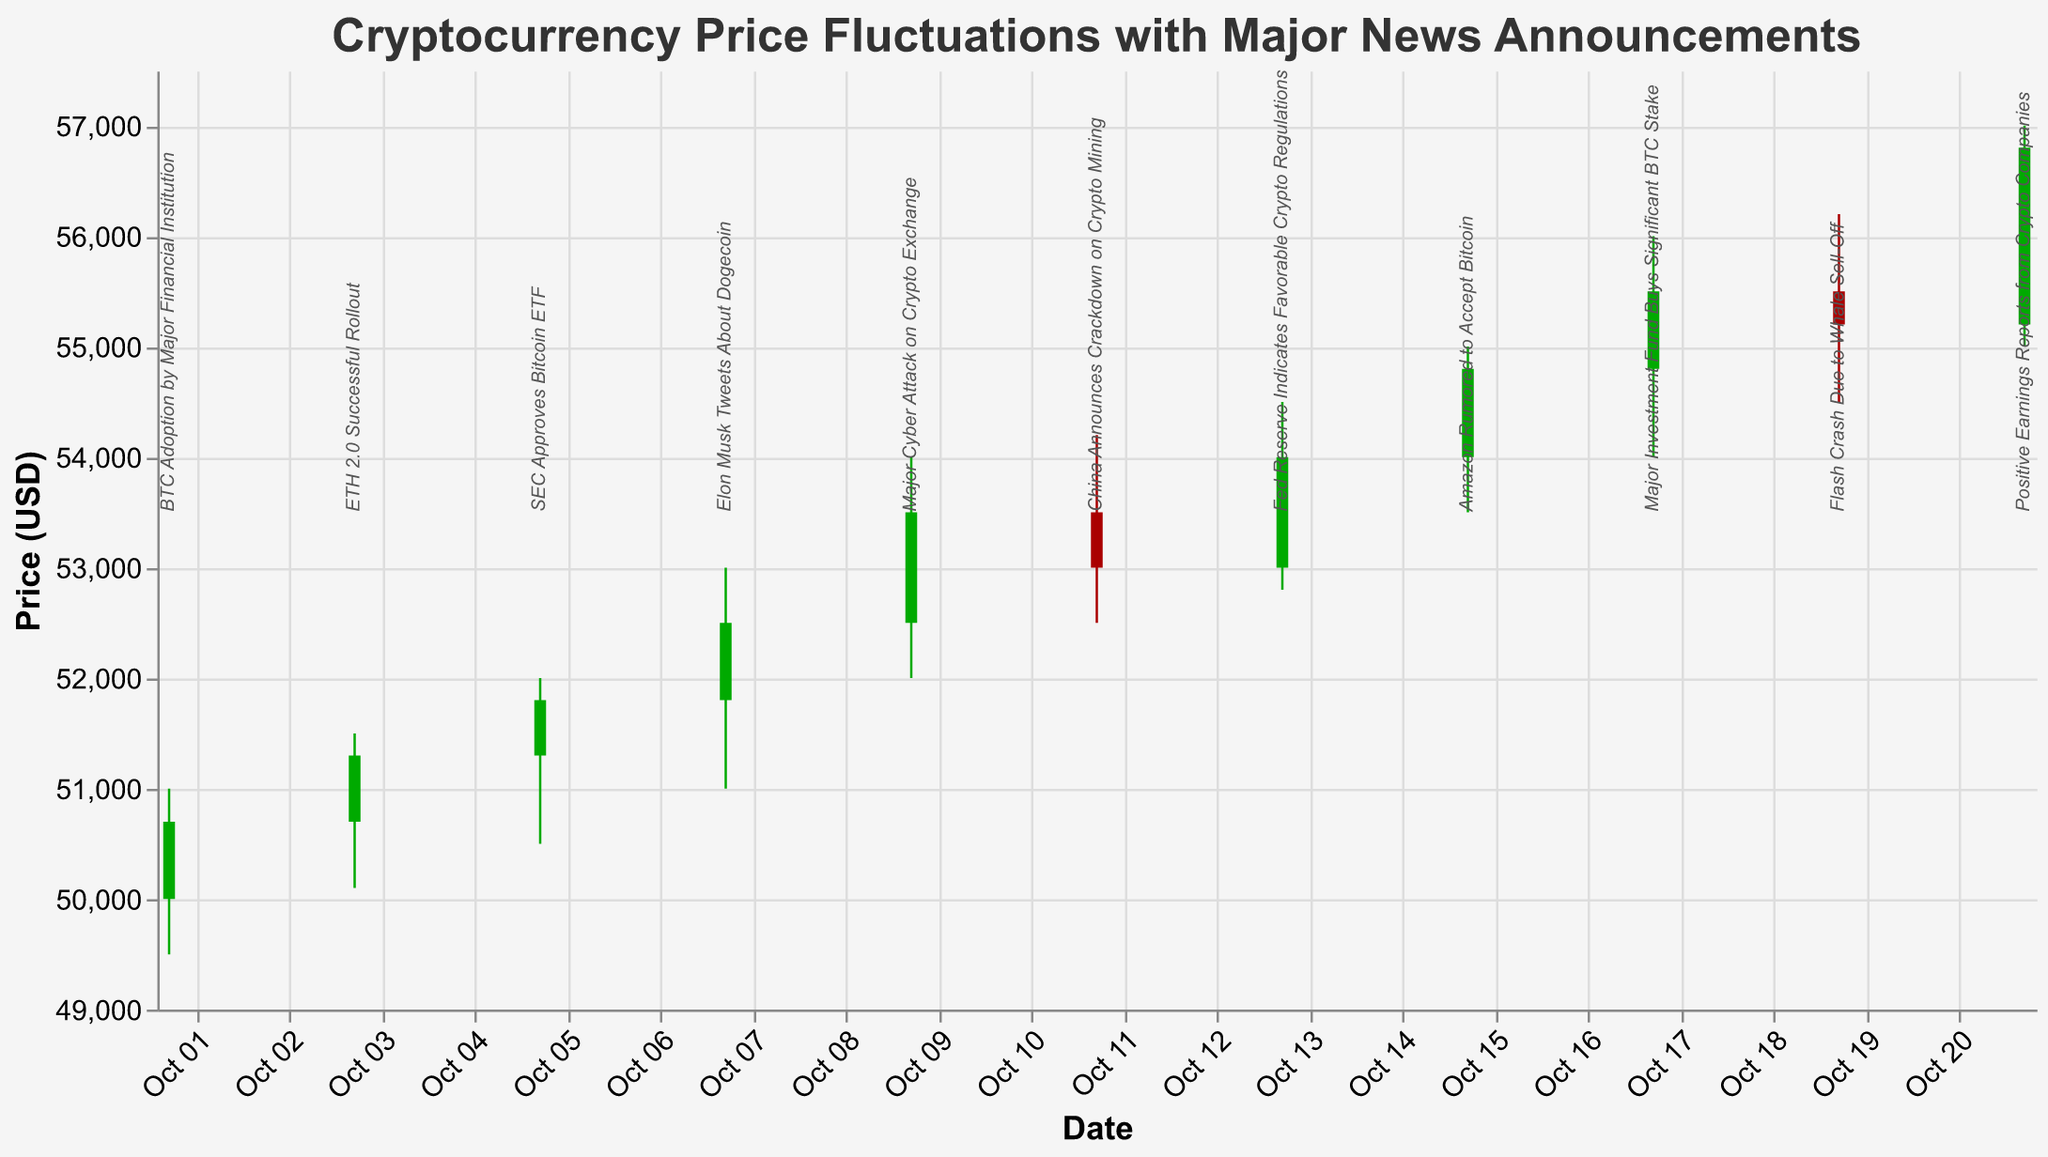What is the title of the figure? The title is displayed at the top of the figure.
Answer: Cryptocurrency Price Fluctuations with Major News Announcements How many candlesticks are there in the figure? Each candlestick represents the trading activity of a particular date. Counting them gives the number of candlesticks.
Answer: 11 What is the date with the highest close price? Checking the 'Close' prices and identifying the highest one.
Answer: October 21 What color are the candlesticks where the close price is higher than the open price? The color is based on a condition where the close price is higher than the open price.
Answer: Green What is the average closing price over all dates in October? Adding the closing prices and dividing by the number of data points. (50700+51300+51800+52500+53500+53000+54000+54800+55500+55200+56800)/11
Answer: 53627.27 What is the total volume of trades on dates where a positive news announcement was made? Summing the volumes for dates with positive news annotations. (350000+420000+310000+400000+410000+385000+420000+450000)
Answer: 3145000 Which date had the highest trading volume? Comparing the trading volumes on all dates to find the highest one.
Answer: October 21 On which date was the price difference between the high and low the largest? Calculating the difference (High - Low) for each date and comparing them.
Answer: October 21 Which event had the most significant immediate positive impact on the closing price? Evaluating the closing price before and after each positive news announcement.
Answer: Amazon Rumored to Accept Bitcoin What was the closing price on the date of "Elon Musk Tweets About Dogecoin"? Looking at the candlestick for October 7 and noting the closing price.
Answer: 52500 On which date did the close price drop despite a positive news announcement? Checking for days with positive news where the close price is less than the open price.
Answer: October 19 